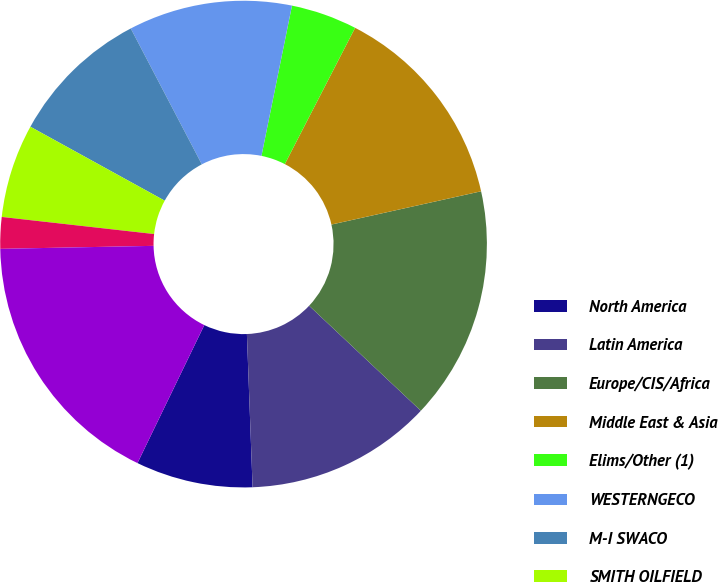Convert chart to OTSL. <chart><loc_0><loc_0><loc_500><loc_500><pie_chart><fcel>North America<fcel>Latin America<fcel>Europe/CIS/Africa<fcel>Middle East & Asia<fcel>Elims/Other (1)<fcel>WESTERNGECO<fcel>M-I SWACO<fcel>SMITH OILFIELD<fcel>DISTRIBUTION<fcel>Corporate (2)<nl><fcel>7.77%<fcel>12.4%<fcel>15.49%<fcel>13.94%<fcel>4.39%<fcel>10.86%<fcel>9.32%<fcel>6.23%<fcel>2.09%<fcel>17.51%<nl></chart> 